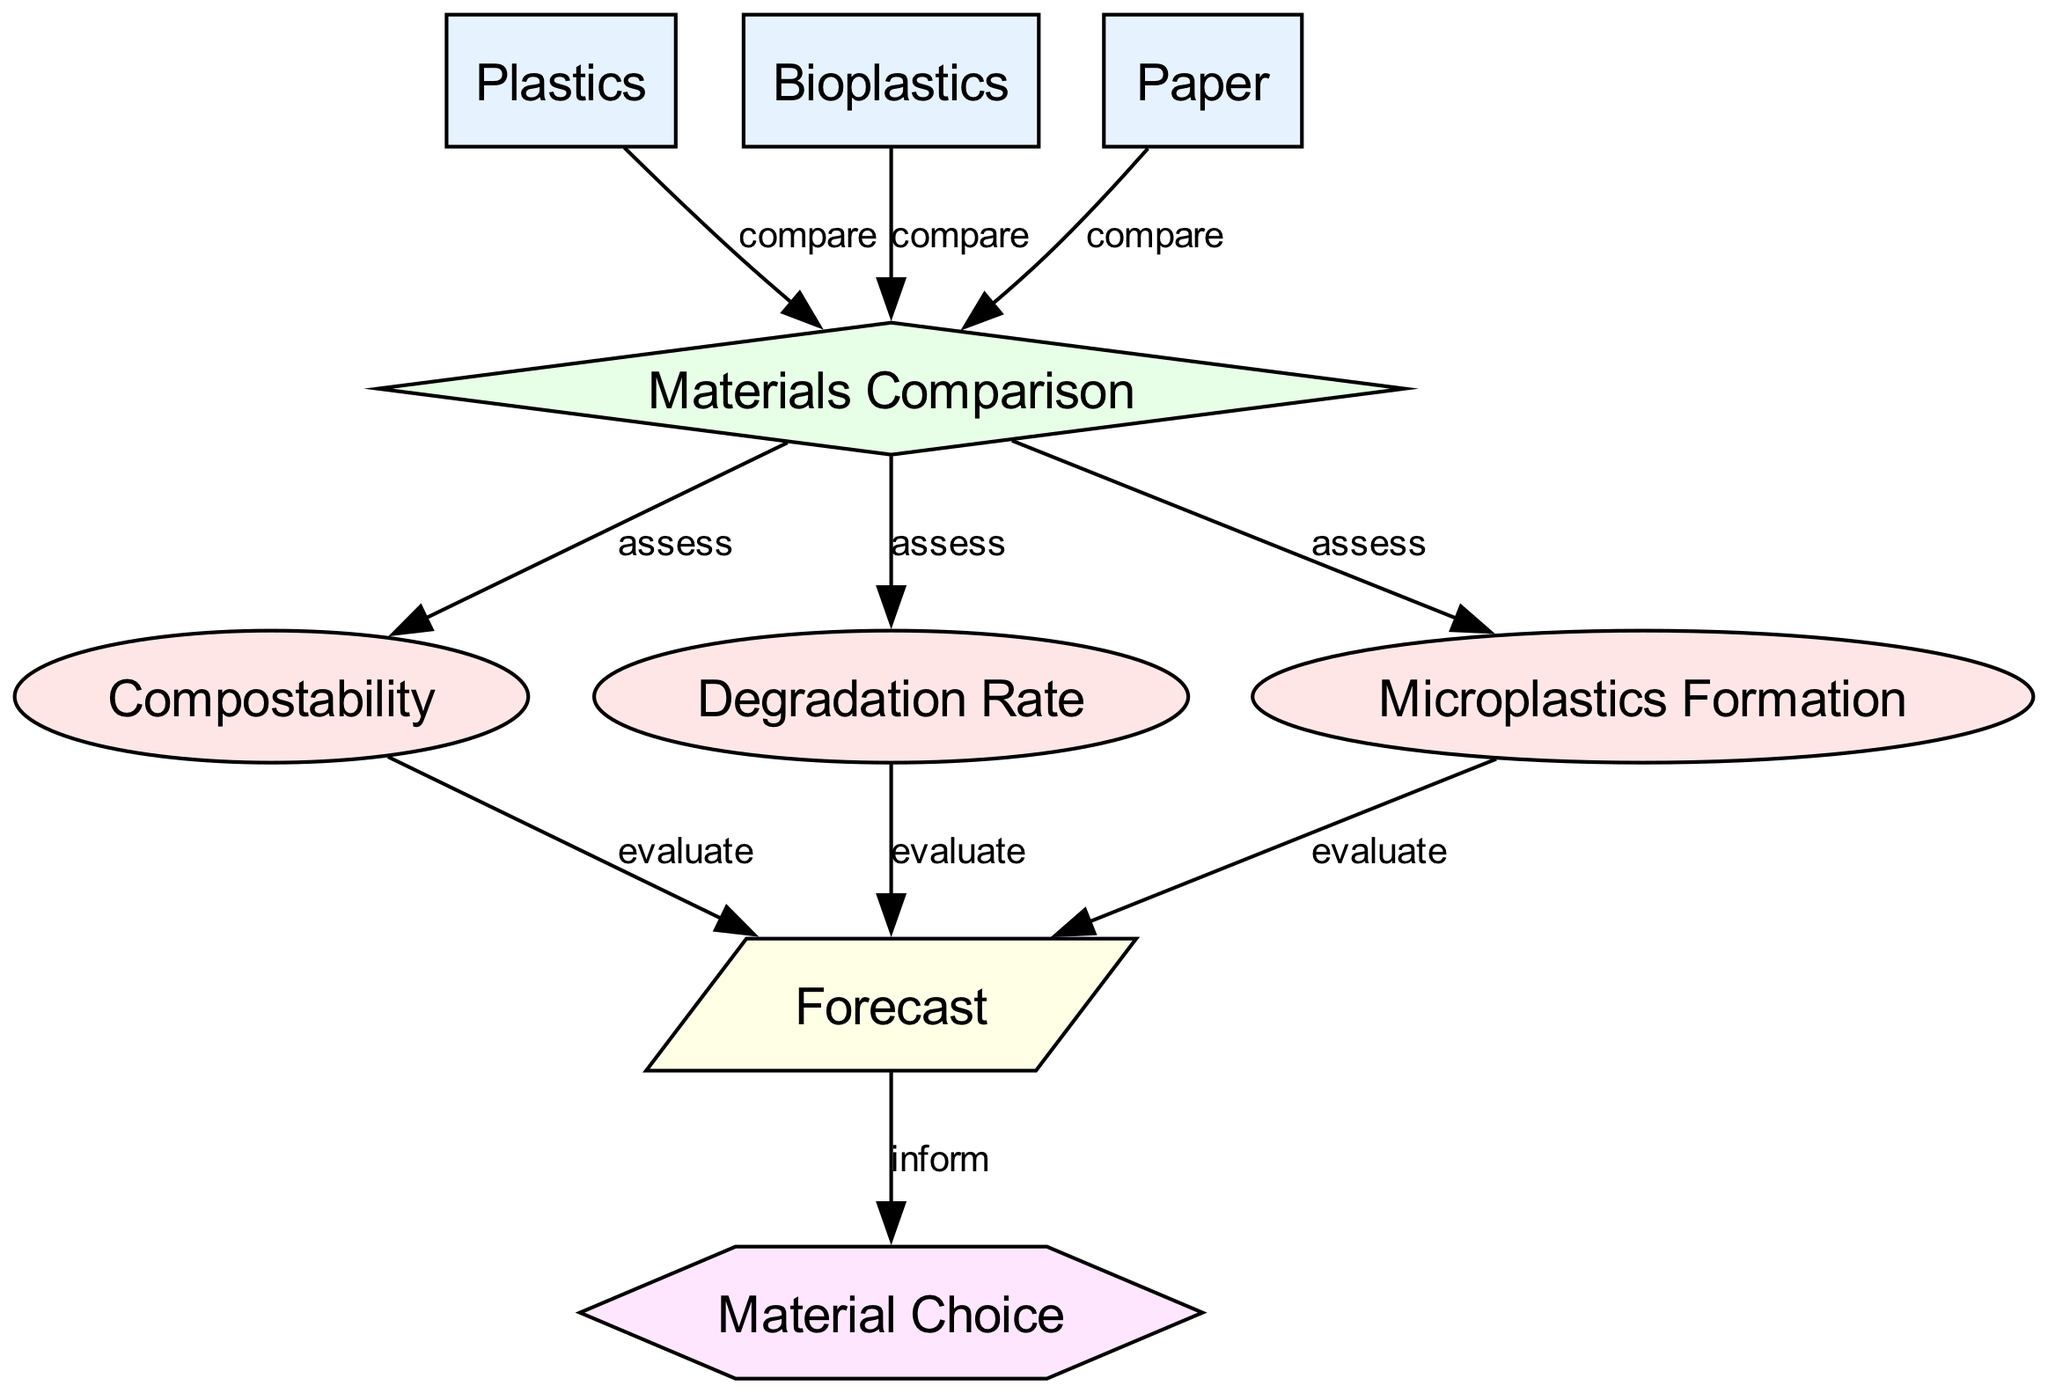What materials are compared in the diagram? The nodes representing materials include "Plastics," "Bioplastics," and "Paper." They are directly linked to the "Materials Comparison" sub-process indicating they are the materials being compared.
Answer: Plastics, Bioplastics, Paper What is assessed in the "Materials Comparison" process? The "Materials Comparison" node has edges leading to three properties: "Compostability," "Degradation Rate," and "Microplastics Formation." This indicates that these properties are assessed during the comparison process.
Answer: Compostability, Degradation Rate, Microplastics Formation How many nodes are involved in the comparison between materials? The nodes for "Plastics," "Bioplastics," "Paper," and "Materials Comparison" indicate a total of four nodes directly involved in comparing the materials.
Answer: Four What is the outcome of evaluating "Compostability," "Degradation Rate," and "Microplastics Formation"? Each of these properties leads to the "Forecast" node, indicating that evaluating them provides the necessary information for drawing a forecast on biodegradability.
Answer: Forecast What type of decision is influenced by the "Forecast"? The "Forecast" node has an edge leading to the "Material Choice" node, signifying that the forecast influences the decision regarding which material to choose for packaging.
Answer: Material Choice What type of relationship exists between "Microplastics Formation" and "Forecast"? There is a directed edge from "Microplastics Formation" to "Forecast," indicating that the evaluation of microplastics formation informs the forecast on biodegradability.
Answer: Evaluate Which material has the highest potential for compostability based on the diagram? The diagram allows for comparison of compostability among "Plastics," "Bioplastics," and "Paper," with "Bioplastics" typically being recognized for better compostability. However, the specific diagram does not quantify or directly indicate values.
Answer: Bioplastics (implied and generally accepted) What type of property is "Degradation Rate"? "Degradation Rate" is classified as a property in the diagram, as shown by its node type, which corresponds to an ellipse.
Answer: Property 